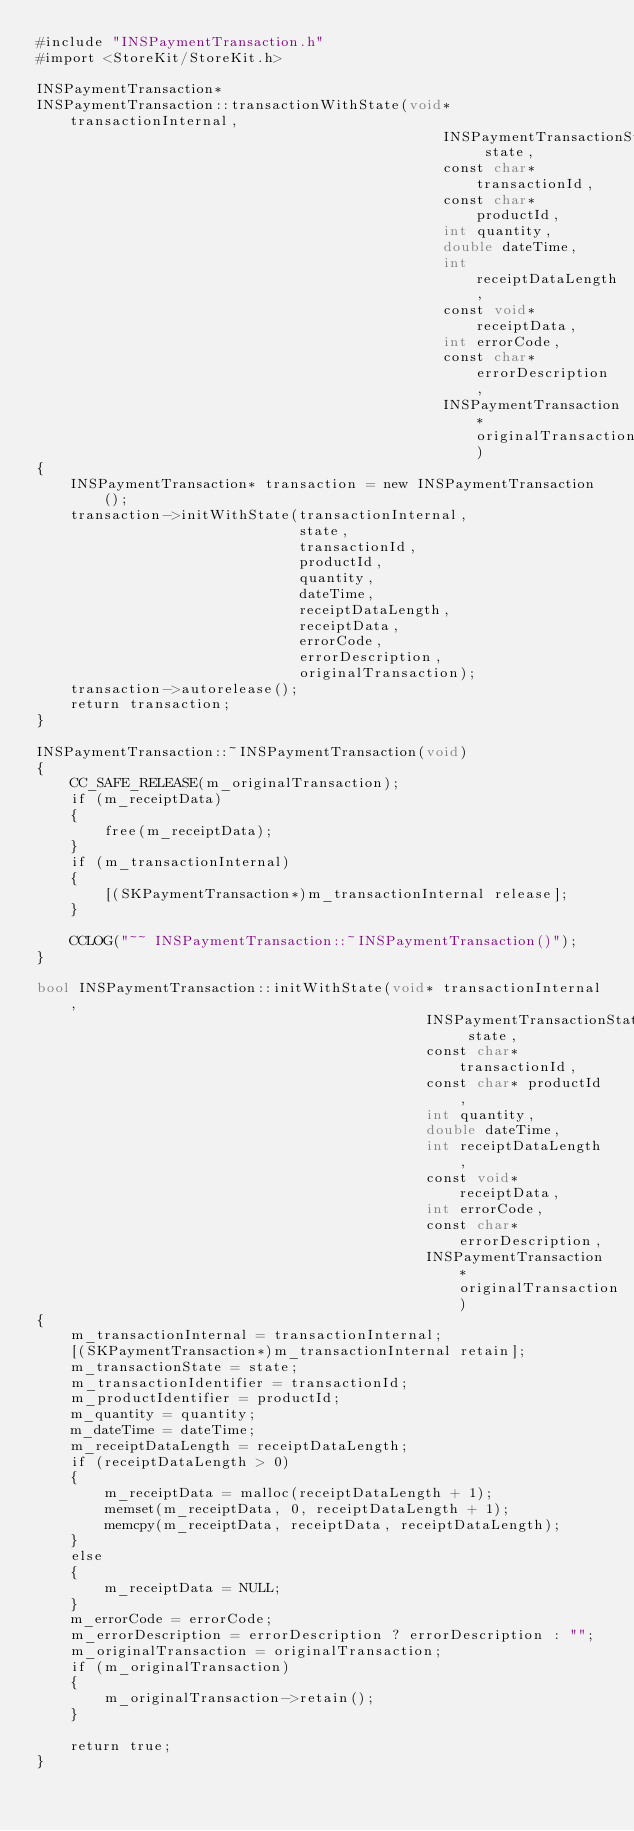<code> <loc_0><loc_0><loc_500><loc_500><_ObjectiveC_>#include "INSPaymentTransaction.h"
#import <StoreKit/StoreKit.h>

INSPaymentTransaction*
INSPaymentTransaction::transactionWithState(void* transactionInternal,
                                                INSPaymentTransactionState state,
                                                const char* transactionId,
                                                const char* productId,
                                                int quantity,
                                                double dateTime,
                                                int receiptDataLength,
                                                const void* receiptData,
                                                int errorCode,
                                                const char* errorDescription,
                                                INSPaymentTransaction* originalTransaction)
{
    INSPaymentTransaction* transaction = new INSPaymentTransaction();
    transaction->initWithState(transactionInternal,
                               state,
                               transactionId,
                               productId,
                               quantity,
                               dateTime,
                               receiptDataLength,
                               receiptData,
                               errorCode,
                               errorDescription,
                               originalTransaction);
    transaction->autorelease();
    return transaction;
}

INSPaymentTransaction::~INSPaymentTransaction(void)
{
    CC_SAFE_RELEASE(m_originalTransaction);
    if (m_receiptData)
    {
        free(m_receiptData);
    }
    if (m_transactionInternal)
    {
        [(SKPaymentTransaction*)m_transactionInternal release];
    }
    
    CCLOG("~~ INSPaymentTransaction::~INSPaymentTransaction()");
}

bool INSPaymentTransaction::initWithState(void* transactionInternal,
                                              INSPaymentTransactionState state,
                                              const char* transactionId,
                                              const char* productId,
                                              int quantity,
                                              double dateTime,
                                              int receiptDataLength,
                                              const void* receiptData,
                                              int errorCode,
                                              const char* errorDescription,
                                              INSPaymentTransaction* originalTransaction)
{
    m_transactionInternal = transactionInternal;
    [(SKPaymentTransaction*)m_transactionInternal retain];
    m_transactionState = state;
    m_transactionIdentifier = transactionId;
    m_productIdentifier = productId;
    m_quantity = quantity;
    m_dateTime = dateTime;
    m_receiptDataLength = receiptDataLength;
    if (receiptDataLength > 0)
    {
        m_receiptData = malloc(receiptDataLength + 1);
        memset(m_receiptData, 0, receiptDataLength + 1);
        memcpy(m_receiptData, receiptData, receiptDataLength);
    }
    else
    {
        m_receiptData = NULL;
    }
    m_errorCode = errorCode;
    m_errorDescription = errorDescription ? errorDescription : "";
    m_originalTransaction = originalTransaction;
    if (m_originalTransaction)
    {
        m_originalTransaction->retain();
    }
    
    return true;
}



</code> 